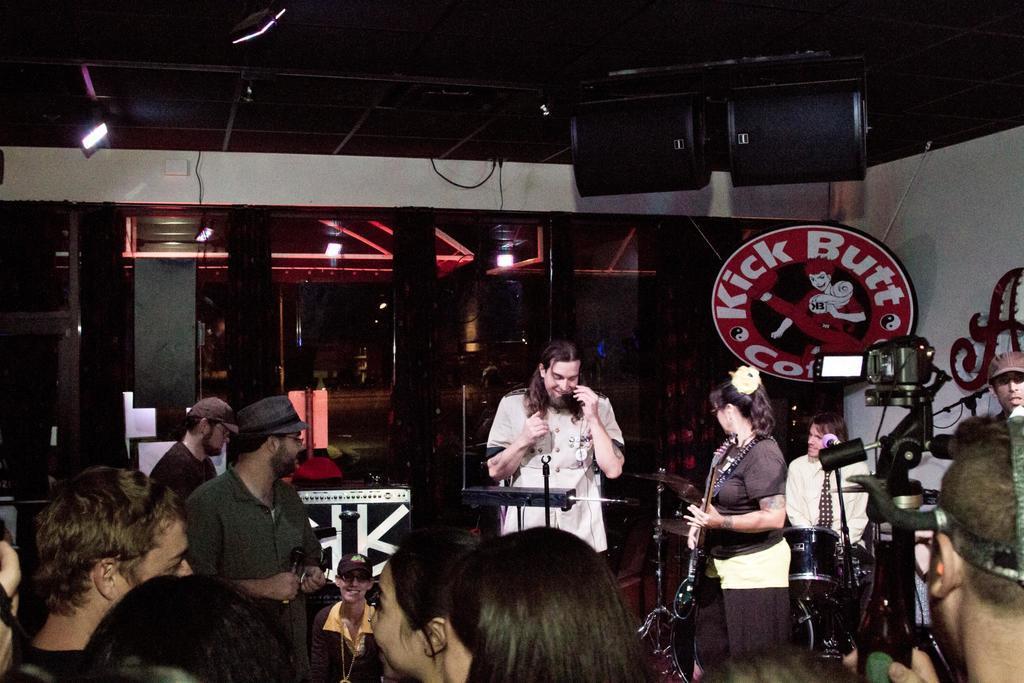How would you summarize this image in a sentence or two? In this image I can see group of people standing. Among them one person is holding musical instrument and another one is holding the mic and he is wearing the cap. To the right there is a camera. In front of them there are people standing. In the back one person is siting in front of drum set and wearing a cream color shirt and brown tie. In the back there is a board. 